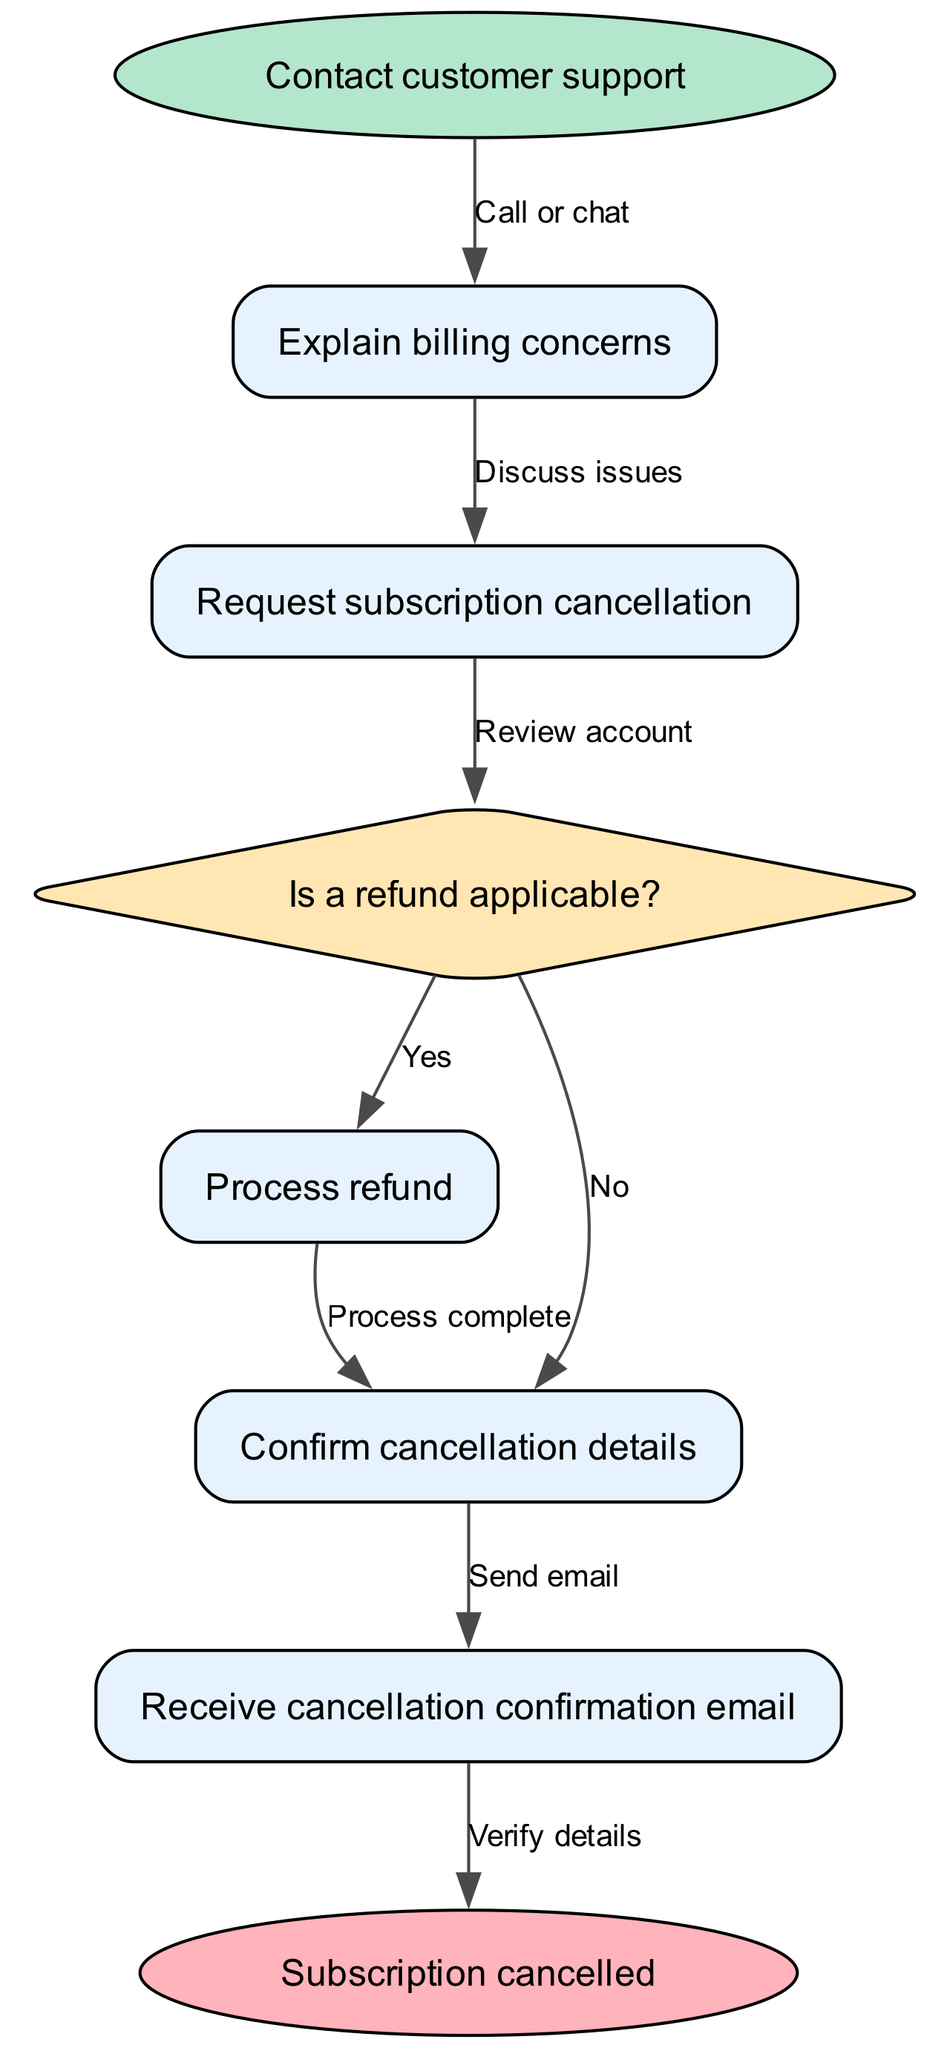What is the first step in the cancellation procedure? The first step is to contact customer support, as indicated at the beginning of the diagram.
Answer: Contact customer support What type of question does the second step address? The second step involves requesting subscription cancellation, following the explanation of billing concerns that was discussed in the first step.
Answer: Request subscription cancellation How many decisions are present in the diagram? There is one decision present in the diagram, which is whether a refund is applicable.
Answer: One What happens if a refund is not applicable? If a refund is not applicable, the process moves to confirming cancellation details, as mapped out in the flow from the decision point through the 'No' edge.
Answer: Confirm cancellation details What is the final output of this cancellation process? The final output, after following all steps and confirming via email, is that the subscription is cancelled.
Answer: Subscription cancelled If a refund is applicable, what is the next action taken? If a refund is applicable, the next action taken is to process the refund, as indicated by the flow from the 'Yes' edge leading to the refund processing step.
Answer: Process refund How many steps involve confirming details? There are two steps that involve confirming details: one for cancellation details and another for receiving an email confirmation, demonstrating that verification is necessary at both points.
Answer: Two steps Which node indicates that an email will be sent? The step that indicates an email will be sent is the one confirming cancellation details; the flow shows that after confirming details, an email directive follows.
Answer: Send email What step follows receiving the cancellation confirmation email? The step following receipt of the cancellation confirmation email involves verifying details, completing the cancellation process to ensure everything is correctly finalized.
Answer: Verify details 